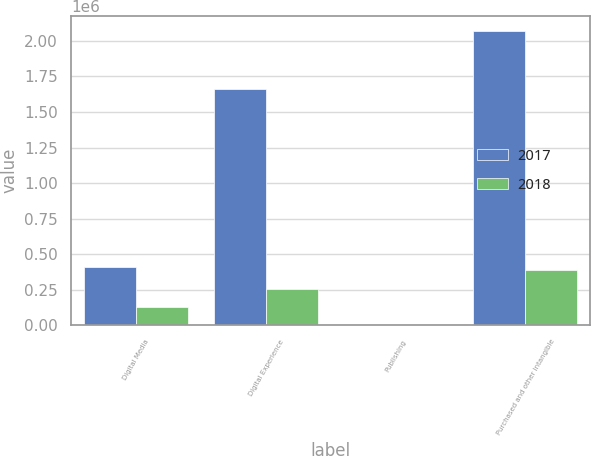Convert chart. <chart><loc_0><loc_0><loc_500><loc_500><stacked_bar_chart><ecel><fcel>Digital Media<fcel>Digital Experience<fcel>Publishing<fcel>Purchased and other intangible<nl><fcel>2017<fcel>408602<fcel>1.6604e+06<fcel>3<fcel>2.069e+06<nl><fcel>2018<fcel>128243<fcel>257408<fcel>7<fcel>385658<nl></chart> 